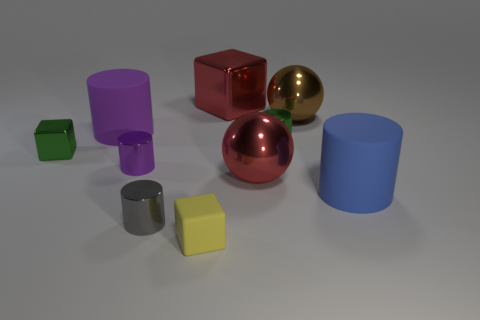Subtract all small green shiny cylinders. How many cylinders are left? 4 Subtract all brown cubes. How many purple cylinders are left? 2 Subtract 1 cubes. How many cubes are left? 2 Subtract all red blocks. How many blocks are left? 2 Subtract all balls. How many objects are left? 8 Add 2 small yellow matte blocks. How many small yellow matte blocks exist? 3 Subtract 1 blue cylinders. How many objects are left? 9 Subtract all blue cubes. Subtract all green cylinders. How many cubes are left? 3 Subtract all large brown shiny cylinders. Subtract all small yellow things. How many objects are left? 9 Add 5 brown objects. How many brown objects are left? 6 